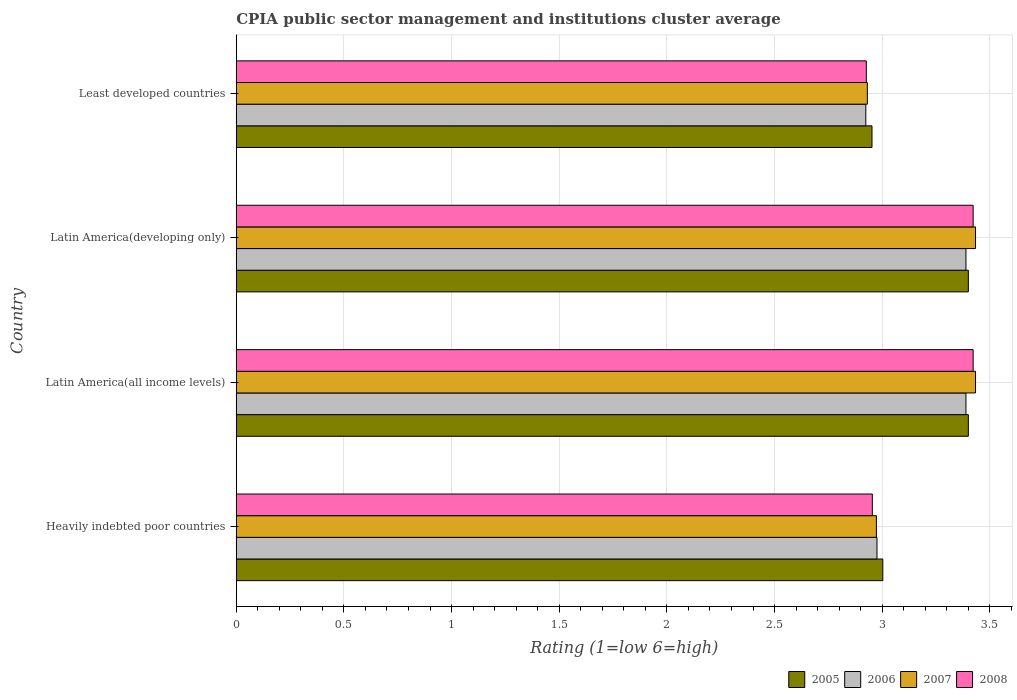How many groups of bars are there?
Provide a succinct answer. 4. How many bars are there on the 3rd tick from the top?
Provide a short and direct response. 4. What is the label of the 4th group of bars from the top?
Make the answer very short. Heavily indebted poor countries. What is the CPIA rating in 2008 in Latin America(all income levels)?
Keep it short and to the point. 3.42. Across all countries, what is the maximum CPIA rating in 2007?
Ensure brevity in your answer.  3.43. Across all countries, what is the minimum CPIA rating in 2007?
Your response must be concise. 2.93. In which country was the CPIA rating in 2007 maximum?
Offer a terse response. Latin America(all income levels). In which country was the CPIA rating in 2006 minimum?
Ensure brevity in your answer.  Least developed countries. What is the total CPIA rating in 2006 in the graph?
Give a very brief answer. 12.68. What is the difference between the CPIA rating in 2007 in Latin America(developing only) and that in Least developed countries?
Make the answer very short. 0.5. What is the difference between the CPIA rating in 2007 in Latin America(all income levels) and the CPIA rating in 2008 in Latin America(developing only)?
Keep it short and to the point. 0.01. What is the average CPIA rating in 2007 per country?
Ensure brevity in your answer.  3.19. What is the difference between the CPIA rating in 2005 and CPIA rating in 2006 in Heavily indebted poor countries?
Your answer should be compact. 0.03. In how many countries, is the CPIA rating in 2006 greater than 3.3 ?
Provide a succinct answer. 2. What is the ratio of the CPIA rating in 2006 in Heavily indebted poor countries to that in Latin America(all income levels)?
Your answer should be very brief. 0.88. Is the CPIA rating in 2008 in Latin America(all income levels) less than that in Latin America(developing only)?
Ensure brevity in your answer.  No. Is the difference between the CPIA rating in 2005 in Latin America(all income levels) and Least developed countries greater than the difference between the CPIA rating in 2006 in Latin America(all income levels) and Least developed countries?
Give a very brief answer. No. What is the difference between the highest and the lowest CPIA rating in 2006?
Give a very brief answer. 0.47. In how many countries, is the CPIA rating in 2006 greater than the average CPIA rating in 2006 taken over all countries?
Offer a very short reply. 2. Is the sum of the CPIA rating in 2007 in Heavily indebted poor countries and Latin America(all income levels) greater than the maximum CPIA rating in 2005 across all countries?
Your answer should be compact. Yes. What does the 4th bar from the top in Latin America(all income levels) represents?
Your answer should be very brief. 2005. What does the 2nd bar from the bottom in Least developed countries represents?
Provide a succinct answer. 2006. Does the graph contain any zero values?
Your response must be concise. No. Where does the legend appear in the graph?
Offer a terse response. Bottom right. How many legend labels are there?
Give a very brief answer. 4. What is the title of the graph?
Your response must be concise. CPIA public sector management and institutions cluster average. Does "1974" appear as one of the legend labels in the graph?
Provide a short and direct response. No. What is the label or title of the X-axis?
Your response must be concise. Rating (1=low 6=high). What is the label or title of the Y-axis?
Ensure brevity in your answer.  Country. What is the Rating (1=low 6=high) of 2005 in Heavily indebted poor countries?
Offer a very short reply. 3. What is the Rating (1=low 6=high) of 2006 in Heavily indebted poor countries?
Offer a terse response. 2.98. What is the Rating (1=low 6=high) in 2007 in Heavily indebted poor countries?
Provide a short and direct response. 2.97. What is the Rating (1=low 6=high) in 2008 in Heavily indebted poor countries?
Offer a terse response. 2.95. What is the Rating (1=low 6=high) of 2006 in Latin America(all income levels)?
Provide a succinct answer. 3.39. What is the Rating (1=low 6=high) of 2007 in Latin America(all income levels)?
Keep it short and to the point. 3.43. What is the Rating (1=low 6=high) in 2008 in Latin America(all income levels)?
Ensure brevity in your answer.  3.42. What is the Rating (1=low 6=high) in 2005 in Latin America(developing only)?
Your response must be concise. 3.4. What is the Rating (1=low 6=high) of 2006 in Latin America(developing only)?
Make the answer very short. 3.39. What is the Rating (1=low 6=high) of 2007 in Latin America(developing only)?
Your response must be concise. 3.43. What is the Rating (1=low 6=high) of 2008 in Latin America(developing only)?
Offer a very short reply. 3.42. What is the Rating (1=low 6=high) in 2005 in Least developed countries?
Provide a short and direct response. 2.95. What is the Rating (1=low 6=high) of 2006 in Least developed countries?
Provide a succinct answer. 2.92. What is the Rating (1=low 6=high) in 2007 in Least developed countries?
Keep it short and to the point. 2.93. What is the Rating (1=low 6=high) in 2008 in Least developed countries?
Provide a succinct answer. 2.93. Across all countries, what is the maximum Rating (1=low 6=high) of 2006?
Provide a succinct answer. 3.39. Across all countries, what is the maximum Rating (1=low 6=high) of 2007?
Your response must be concise. 3.43. Across all countries, what is the maximum Rating (1=low 6=high) of 2008?
Your answer should be very brief. 3.42. Across all countries, what is the minimum Rating (1=low 6=high) in 2005?
Your answer should be very brief. 2.95. Across all countries, what is the minimum Rating (1=low 6=high) of 2006?
Keep it short and to the point. 2.92. Across all countries, what is the minimum Rating (1=low 6=high) of 2007?
Your answer should be very brief. 2.93. Across all countries, what is the minimum Rating (1=low 6=high) in 2008?
Provide a succinct answer. 2.93. What is the total Rating (1=low 6=high) in 2005 in the graph?
Your answer should be very brief. 12.76. What is the total Rating (1=low 6=high) in 2006 in the graph?
Your response must be concise. 12.68. What is the total Rating (1=low 6=high) in 2007 in the graph?
Your answer should be very brief. 12.77. What is the total Rating (1=low 6=high) of 2008 in the graph?
Offer a very short reply. 12.72. What is the difference between the Rating (1=low 6=high) in 2005 in Heavily indebted poor countries and that in Latin America(all income levels)?
Give a very brief answer. -0.4. What is the difference between the Rating (1=low 6=high) in 2006 in Heavily indebted poor countries and that in Latin America(all income levels)?
Offer a very short reply. -0.41. What is the difference between the Rating (1=low 6=high) in 2007 in Heavily indebted poor countries and that in Latin America(all income levels)?
Provide a succinct answer. -0.46. What is the difference between the Rating (1=low 6=high) in 2008 in Heavily indebted poor countries and that in Latin America(all income levels)?
Provide a short and direct response. -0.47. What is the difference between the Rating (1=low 6=high) of 2005 in Heavily indebted poor countries and that in Latin America(developing only)?
Your response must be concise. -0.4. What is the difference between the Rating (1=low 6=high) of 2006 in Heavily indebted poor countries and that in Latin America(developing only)?
Provide a succinct answer. -0.41. What is the difference between the Rating (1=low 6=high) in 2007 in Heavily indebted poor countries and that in Latin America(developing only)?
Offer a terse response. -0.46. What is the difference between the Rating (1=low 6=high) of 2008 in Heavily indebted poor countries and that in Latin America(developing only)?
Offer a very short reply. -0.47. What is the difference between the Rating (1=low 6=high) of 2005 in Heavily indebted poor countries and that in Least developed countries?
Provide a succinct answer. 0.05. What is the difference between the Rating (1=low 6=high) in 2006 in Heavily indebted poor countries and that in Least developed countries?
Your answer should be very brief. 0.05. What is the difference between the Rating (1=low 6=high) of 2007 in Heavily indebted poor countries and that in Least developed countries?
Ensure brevity in your answer.  0.04. What is the difference between the Rating (1=low 6=high) of 2008 in Heavily indebted poor countries and that in Least developed countries?
Your answer should be very brief. 0.03. What is the difference between the Rating (1=low 6=high) in 2006 in Latin America(all income levels) and that in Latin America(developing only)?
Offer a terse response. 0. What is the difference between the Rating (1=low 6=high) in 2005 in Latin America(all income levels) and that in Least developed countries?
Make the answer very short. 0.45. What is the difference between the Rating (1=low 6=high) in 2006 in Latin America(all income levels) and that in Least developed countries?
Your response must be concise. 0.47. What is the difference between the Rating (1=low 6=high) of 2007 in Latin America(all income levels) and that in Least developed countries?
Your answer should be very brief. 0.5. What is the difference between the Rating (1=low 6=high) in 2008 in Latin America(all income levels) and that in Least developed countries?
Give a very brief answer. 0.5. What is the difference between the Rating (1=low 6=high) in 2005 in Latin America(developing only) and that in Least developed countries?
Provide a short and direct response. 0.45. What is the difference between the Rating (1=low 6=high) in 2006 in Latin America(developing only) and that in Least developed countries?
Your answer should be very brief. 0.47. What is the difference between the Rating (1=low 6=high) of 2007 in Latin America(developing only) and that in Least developed countries?
Your answer should be very brief. 0.5. What is the difference between the Rating (1=low 6=high) of 2008 in Latin America(developing only) and that in Least developed countries?
Offer a terse response. 0.5. What is the difference between the Rating (1=low 6=high) in 2005 in Heavily indebted poor countries and the Rating (1=low 6=high) in 2006 in Latin America(all income levels)?
Ensure brevity in your answer.  -0.39. What is the difference between the Rating (1=low 6=high) of 2005 in Heavily indebted poor countries and the Rating (1=low 6=high) of 2007 in Latin America(all income levels)?
Offer a terse response. -0.43. What is the difference between the Rating (1=low 6=high) of 2005 in Heavily indebted poor countries and the Rating (1=low 6=high) of 2008 in Latin America(all income levels)?
Offer a very short reply. -0.42. What is the difference between the Rating (1=low 6=high) in 2006 in Heavily indebted poor countries and the Rating (1=low 6=high) in 2007 in Latin America(all income levels)?
Give a very brief answer. -0.46. What is the difference between the Rating (1=low 6=high) in 2006 in Heavily indebted poor countries and the Rating (1=low 6=high) in 2008 in Latin America(all income levels)?
Keep it short and to the point. -0.45. What is the difference between the Rating (1=low 6=high) of 2007 in Heavily indebted poor countries and the Rating (1=low 6=high) of 2008 in Latin America(all income levels)?
Your answer should be compact. -0.45. What is the difference between the Rating (1=low 6=high) in 2005 in Heavily indebted poor countries and the Rating (1=low 6=high) in 2006 in Latin America(developing only)?
Keep it short and to the point. -0.39. What is the difference between the Rating (1=low 6=high) of 2005 in Heavily indebted poor countries and the Rating (1=low 6=high) of 2007 in Latin America(developing only)?
Give a very brief answer. -0.43. What is the difference between the Rating (1=low 6=high) in 2005 in Heavily indebted poor countries and the Rating (1=low 6=high) in 2008 in Latin America(developing only)?
Provide a succinct answer. -0.42. What is the difference between the Rating (1=low 6=high) in 2006 in Heavily indebted poor countries and the Rating (1=low 6=high) in 2007 in Latin America(developing only)?
Your answer should be very brief. -0.46. What is the difference between the Rating (1=low 6=high) of 2006 in Heavily indebted poor countries and the Rating (1=low 6=high) of 2008 in Latin America(developing only)?
Offer a very short reply. -0.45. What is the difference between the Rating (1=low 6=high) of 2007 in Heavily indebted poor countries and the Rating (1=low 6=high) of 2008 in Latin America(developing only)?
Ensure brevity in your answer.  -0.45. What is the difference between the Rating (1=low 6=high) of 2005 in Heavily indebted poor countries and the Rating (1=low 6=high) of 2006 in Least developed countries?
Ensure brevity in your answer.  0.08. What is the difference between the Rating (1=low 6=high) in 2005 in Heavily indebted poor countries and the Rating (1=low 6=high) in 2007 in Least developed countries?
Keep it short and to the point. 0.07. What is the difference between the Rating (1=low 6=high) in 2005 in Heavily indebted poor countries and the Rating (1=low 6=high) in 2008 in Least developed countries?
Ensure brevity in your answer.  0.08. What is the difference between the Rating (1=low 6=high) of 2006 in Heavily indebted poor countries and the Rating (1=low 6=high) of 2007 in Least developed countries?
Your response must be concise. 0.04. What is the difference between the Rating (1=low 6=high) of 2006 in Heavily indebted poor countries and the Rating (1=low 6=high) of 2008 in Least developed countries?
Your answer should be very brief. 0.05. What is the difference between the Rating (1=low 6=high) in 2007 in Heavily indebted poor countries and the Rating (1=low 6=high) in 2008 in Least developed countries?
Provide a succinct answer. 0.05. What is the difference between the Rating (1=low 6=high) in 2005 in Latin America(all income levels) and the Rating (1=low 6=high) in 2006 in Latin America(developing only)?
Your response must be concise. 0.01. What is the difference between the Rating (1=low 6=high) of 2005 in Latin America(all income levels) and the Rating (1=low 6=high) of 2007 in Latin America(developing only)?
Offer a very short reply. -0.03. What is the difference between the Rating (1=low 6=high) in 2005 in Latin America(all income levels) and the Rating (1=low 6=high) in 2008 in Latin America(developing only)?
Make the answer very short. -0.02. What is the difference between the Rating (1=low 6=high) in 2006 in Latin America(all income levels) and the Rating (1=low 6=high) in 2007 in Latin America(developing only)?
Ensure brevity in your answer.  -0.04. What is the difference between the Rating (1=low 6=high) in 2006 in Latin America(all income levels) and the Rating (1=low 6=high) in 2008 in Latin America(developing only)?
Keep it short and to the point. -0.03. What is the difference between the Rating (1=low 6=high) of 2007 in Latin America(all income levels) and the Rating (1=low 6=high) of 2008 in Latin America(developing only)?
Offer a very short reply. 0.01. What is the difference between the Rating (1=low 6=high) of 2005 in Latin America(all income levels) and the Rating (1=low 6=high) of 2006 in Least developed countries?
Your response must be concise. 0.48. What is the difference between the Rating (1=low 6=high) in 2005 in Latin America(all income levels) and the Rating (1=low 6=high) in 2007 in Least developed countries?
Give a very brief answer. 0.47. What is the difference between the Rating (1=low 6=high) in 2005 in Latin America(all income levels) and the Rating (1=low 6=high) in 2008 in Least developed countries?
Keep it short and to the point. 0.47. What is the difference between the Rating (1=low 6=high) in 2006 in Latin America(all income levels) and the Rating (1=low 6=high) in 2007 in Least developed countries?
Provide a short and direct response. 0.46. What is the difference between the Rating (1=low 6=high) in 2006 in Latin America(all income levels) and the Rating (1=low 6=high) in 2008 in Least developed countries?
Keep it short and to the point. 0.46. What is the difference between the Rating (1=low 6=high) in 2007 in Latin America(all income levels) and the Rating (1=low 6=high) in 2008 in Least developed countries?
Make the answer very short. 0.51. What is the difference between the Rating (1=low 6=high) of 2005 in Latin America(developing only) and the Rating (1=low 6=high) of 2006 in Least developed countries?
Provide a short and direct response. 0.48. What is the difference between the Rating (1=low 6=high) of 2005 in Latin America(developing only) and the Rating (1=low 6=high) of 2007 in Least developed countries?
Your answer should be very brief. 0.47. What is the difference between the Rating (1=low 6=high) in 2005 in Latin America(developing only) and the Rating (1=low 6=high) in 2008 in Least developed countries?
Offer a terse response. 0.47. What is the difference between the Rating (1=low 6=high) of 2006 in Latin America(developing only) and the Rating (1=low 6=high) of 2007 in Least developed countries?
Offer a very short reply. 0.46. What is the difference between the Rating (1=low 6=high) in 2006 in Latin America(developing only) and the Rating (1=low 6=high) in 2008 in Least developed countries?
Offer a terse response. 0.46. What is the difference between the Rating (1=low 6=high) of 2007 in Latin America(developing only) and the Rating (1=low 6=high) of 2008 in Least developed countries?
Offer a terse response. 0.51. What is the average Rating (1=low 6=high) of 2005 per country?
Your response must be concise. 3.19. What is the average Rating (1=low 6=high) of 2006 per country?
Make the answer very short. 3.17. What is the average Rating (1=low 6=high) in 2007 per country?
Keep it short and to the point. 3.19. What is the average Rating (1=low 6=high) of 2008 per country?
Offer a very short reply. 3.18. What is the difference between the Rating (1=low 6=high) of 2005 and Rating (1=low 6=high) of 2006 in Heavily indebted poor countries?
Offer a terse response. 0.03. What is the difference between the Rating (1=low 6=high) of 2005 and Rating (1=low 6=high) of 2007 in Heavily indebted poor countries?
Give a very brief answer. 0.03. What is the difference between the Rating (1=low 6=high) of 2005 and Rating (1=low 6=high) of 2008 in Heavily indebted poor countries?
Your answer should be compact. 0.05. What is the difference between the Rating (1=low 6=high) of 2006 and Rating (1=low 6=high) of 2007 in Heavily indebted poor countries?
Keep it short and to the point. 0. What is the difference between the Rating (1=low 6=high) in 2006 and Rating (1=low 6=high) in 2008 in Heavily indebted poor countries?
Give a very brief answer. 0.02. What is the difference between the Rating (1=low 6=high) of 2007 and Rating (1=low 6=high) of 2008 in Heavily indebted poor countries?
Keep it short and to the point. 0.02. What is the difference between the Rating (1=low 6=high) of 2005 and Rating (1=low 6=high) of 2006 in Latin America(all income levels)?
Provide a succinct answer. 0.01. What is the difference between the Rating (1=low 6=high) in 2005 and Rating (1=low 6=high) in 2007 in Latin America(all income levels)?
Your answer should be very brief. -0.03. What is the difference between the Rating (1=low 6=high) of 2005 and Rating (1=low 6=high) of 2008 in Latin America(all income levels)?
Provide a short and direct response. -0.02. What is the difference between the Rating (1=low 6=high) in 2006 and Rating (1=low 6=high) in 2007 in Latin America(all income levels)?
Offer a terse response. -0.04. What is the difference between the Rating (1=low 6=high) of 2006 and Rating (1=low 6=high) of 2008 in Latin America(all income levels)?
Your response must be concise. -0.03. What is the difference between the Rating (1=low 6=high) in 2007 and Rating (1=low 6=high) in 2008 in Latin America(all income levels)?
Provide a succinct answer. 0.01. What is the difference between the Rating (1=low 6=high) of 2005 and Rating (1=low 6=high) of 2006 in Latin America(developing only)?
Your answer should be compact. 0.01. What is the difference between the Rating (1=low 6=high) in 2005 and Rating (1=low 6=high) in 2007 in Latin America(developing only)?
Give a very brief answer. -0.03. What is the difference between the Rating (1=low 6=high) of 2005 and Rating (1=low 6=high) of 2008 in Latin America(developing only)?
Your answer should be very brief. -0.02. What is the difference between the Rating (1=low 6=high) of 2006 and Rating (1=low 6=high) of 2007 in Latin America(developing only)?
Keep it short and to the point. -0.04. What is the difference between the Rating (1=low 6=high) in 2006 and Rating (1=low 6=high) in 2008 in Latin America(developing only)?
Offer a terse response. -0.03. What is the difference between the Rating (1=low 6=high) of 2007 and Rating (1=low 6=high) of 2008 in Latin America(developing only)?
Ensure brevity in your answer.  0.01. What is the difference between the Rating (1=low 6=high) in 2005 and Rating (1=low 6=high) in 2006 in Least developed countries?
Offer a very short reply. 0.03. What is the difference between the Rating (1=low 6=high) of 2005 and Rating (1=low 6=high) of 2007 in Least developed countries?
Offer a terse response. 0.02. What is the difference between the Rating (1=low 6=high) in 2005 and Rating (1=low 6=high) in 2008 in Least developed countries?
Make the answer very short. 0.03. What is the difference between the Rating (1=low 6=high) in 2006 and Rating (1=low 6=high) in 2007 in Least developed countries?
Offer a very short reply. -0.01. What is the difference between the Rating (1=low 6=high) of 2006 and Rating (1=low 6=high) of 2008 in Least developed countries?
Ensure brevity in your answer.  -0. What is the difference between the Rating (1=low 6=high) of 2007 and Rating (1=low 6=high) of 2008 in Least developed countries?
Give a very brief answer. 0. What is the ratio of the Rating (1=low 6=high) of 2005 in Heavily indebted poor countries to that in Latin America(all income levels)?
Your response must be concise. 0.88. What is the ratio of the Rating (1=low 6=high) in 2006 in Heavily indebted poor countries to that in Latin America(all income levels)?
Ensure brevity in your answer.  0.88. What is the ratio of the Rating (1=low 6=high) of 2007 in Heavily indebted poor countries to that in Latin America(all income levels)?
Provide a short and direct response. 0.87. What is the ratio of the Rating (1=low 6=high) in 2008 in Heavily indebted poor countries to that in Latin America(all income levels)?
Keep it short and to the point. 0.86. What is the ratio of the Rating (1=low 6=high) in 2005 in Heavily indebted poor countries to that in Latin America(developing only)?
Provide a short and direct response. 0.88. What is the ratio of the Rating (1=low 6=high) of 2006 in Heavily indebted poor countries to that in Latin America(developing only)?
Your response must be concise. 0.88. What is the ratio of the Rating (1=low 6=high) in 2007 in Heavily indebted poor countries to that in Latin America(developing only)?
Provide a short and direct response. 0.87. What is the ratio of the Rating (1=low 6=high) of 2008 in Heavily indebted poor countries to that in Latin America(developing only)?
Make the answer very short. 0.86. What is the ratio of the Rating (1=low 6=high) of 2005 in Heavily indebted poor countries to that in Least developed countries?
Make the answer very short. 1.02. What is the ratio of the Rating (1=low 6=high) in 2006 in Heavily indebted poor countries to that in Least developed countries?
Your answer should be compact. 1.02. What is the ratio of the Rating (1=low 6=high) of 2007 in Heavily indebted poor countries to that in Least developed countries?
Offer a very short reply. 1.01. What is the ratio of the Rating (1=low 6=high) of 2008 in Heavily indebted poor countries to that in Least developed countries?
Your answer should be compact. 1.01. What is the ratio of the Rating (1=low 6=high) of 2007 in Latin America(all income levels) to that in Latin America(developing only)?
Provide a succinct answer. 1. What is the ratio of the Rating (1=low 6=high) of 2005 in Latin America(all income levels) to that in Least developed countries?
Offer a terse response. 1.15. What is the ratio of the Rating (1=low 6=high) of 2006 in Latin America(all income levels) to that in Least developed countries?
Offer a very short reply. 1.16. What is the ratio of the Rating (1=low 6=high) of 2007 in Latin America(all income levels) to that in Least developed countries?
Ensure brevity in your answer.  1.17. What is the ratio of the Rating (1=low 6=high) of 2008 in Latin America(all income levels) to that in Least developed countries?
Your answer should be compact. 1.17. What is the ratio of the Rating (1=low 6=high) of 2005 in Latin America(developing only) to that in Least developed countries?
Make the answer very short. 1.15. What is the ratio of the Rating (1=low 6=high) of 2006 in Latin America(developing only) to that in Least developed countries?
Your answer should be very brief. 1.16. What is the ratio of the Rating (1=low 6=high) in 2007 in Latin America(developing only) to that in Least developed countries?
Keep it short and to the point. 1.17. What is the ratio of the Rating (1=low 6=high) of 2008 in Latin America(developing only) to that in Least developed countries?
Your response must be concise. 1.17. What is the difference between the highest and the second highest Rating (1=low 6=high) in 2005?
Provide a short and direct response. 0. What is the difference between the highest and the second highest Rating (1=low 6=high) in 2006?
Provide a succinct answer. 0. What is the difference between the highest and the second highest Rating (1=low 6=high) of 2007?
Your response must be concise. 0. What is the difference between the highest and the lowest Rating (1=low 6=high) of 2005?
Your response must be concise. 0.45. What is the difference between the highest and the lowest Rating (1=low 6=high) in 2006?
Keep it short and to the point. 0.47. What is the difference between the highest and the lowest Rating (1=low 6=high) in 2007?
Your answer should be very brief. 0.5. What is the difference between the highest and the lowest Rating (1=low 6=high) of 2008?
Keep it short and to the point. 0.5. 